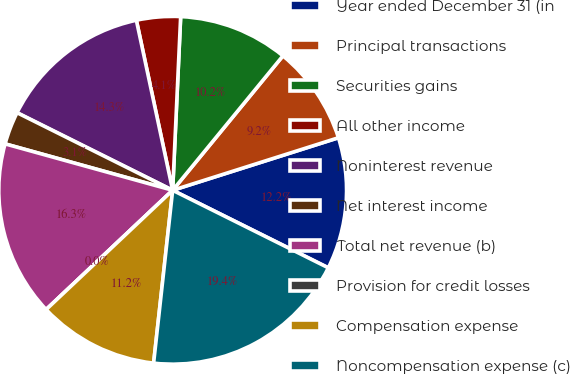Convert chart to OTSL. <chart><loc_0><loc_0><loc_500><loc_500><pie_chart><fcel>Year ended December 31 (in<fcel>Principal transactions<fcel>Securities gains<fcel>All other income<fcel>Noninterest revenue<fcel>Net interest income<fcel>Total net revenue (b)<fcel>Provision for credit losses<fcel>Compensation expense<fcel>Noncompensation expense (c)<nl><fcel>12.24%<fcel>9.18%<fcel>10.2%<fcel>4.08%<fcel>14.29%<fcel>3.06%<fcel>16.33%<fcel>0.0%<fcel>11.22%<fcel>19.39%<nl></chart> 